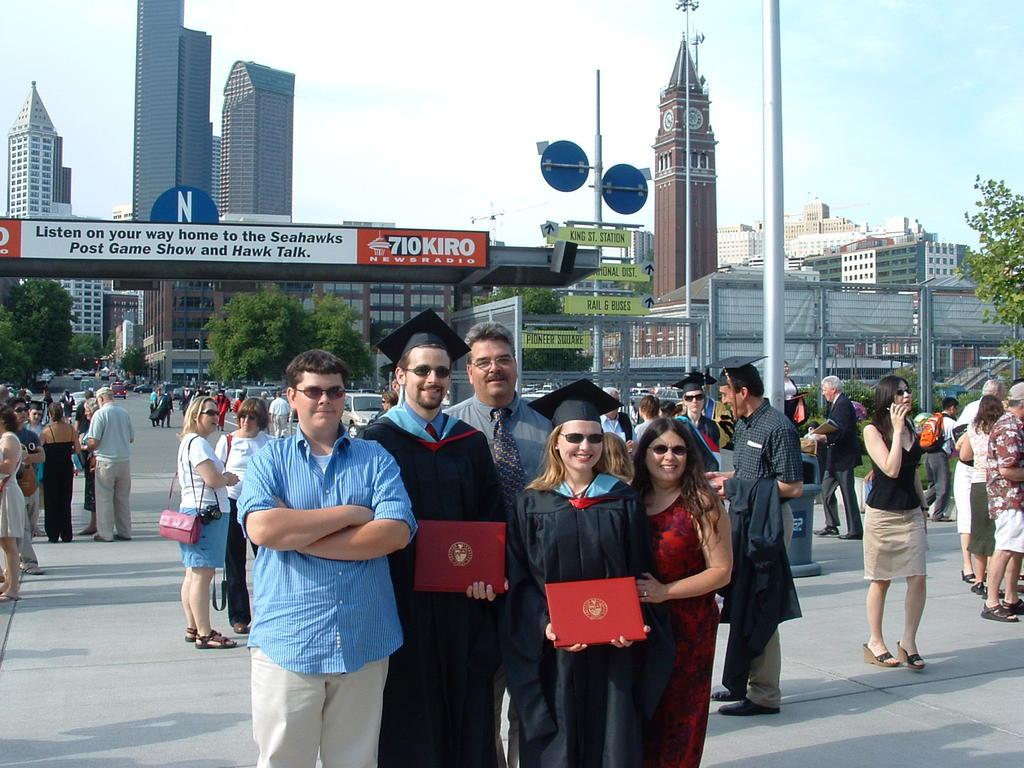Provide a one-sentence caption for the provided image. Two graduates stand in front of a sign that advertises for the Seahawk's post game show. 